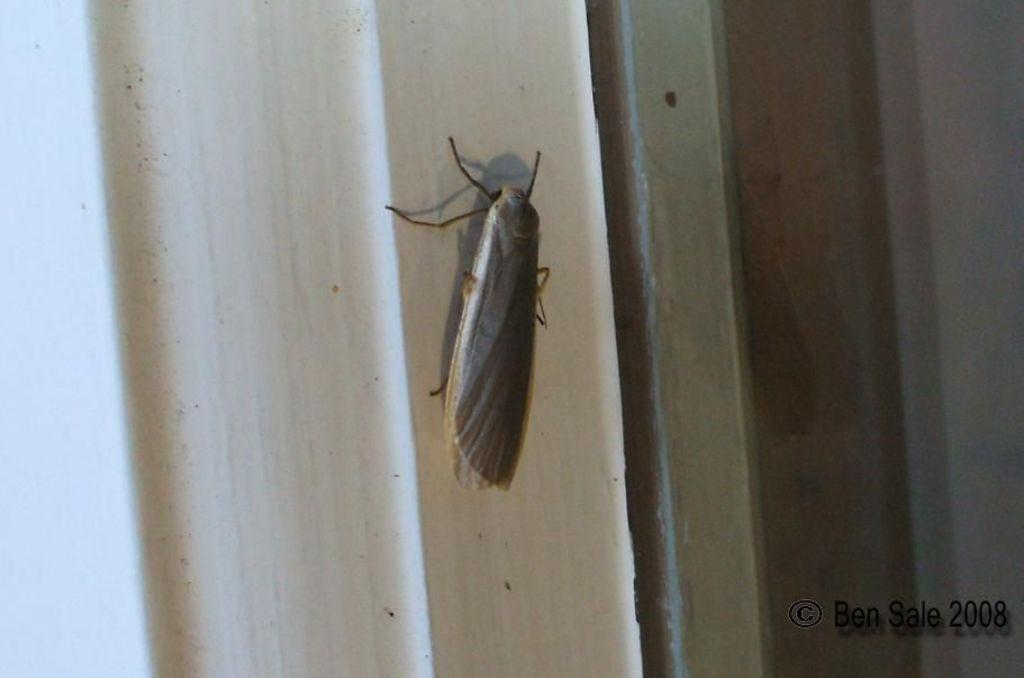What type of creature can be seen in the image? There is an insect in the image. What is visible in the background of the image? There is a wall in the background of the image. How is the wall depicted in the image? The wall appears to be truncated. What type of written information is present in the image? There is text in the image. Is there any numerical information in the image? Yes, there is a number in the image. Can you see any fangs on the insect in the image? There is no mention of fangs or any specific insect type in the provided facts, so it cannot be determined if the insect has fangs. 